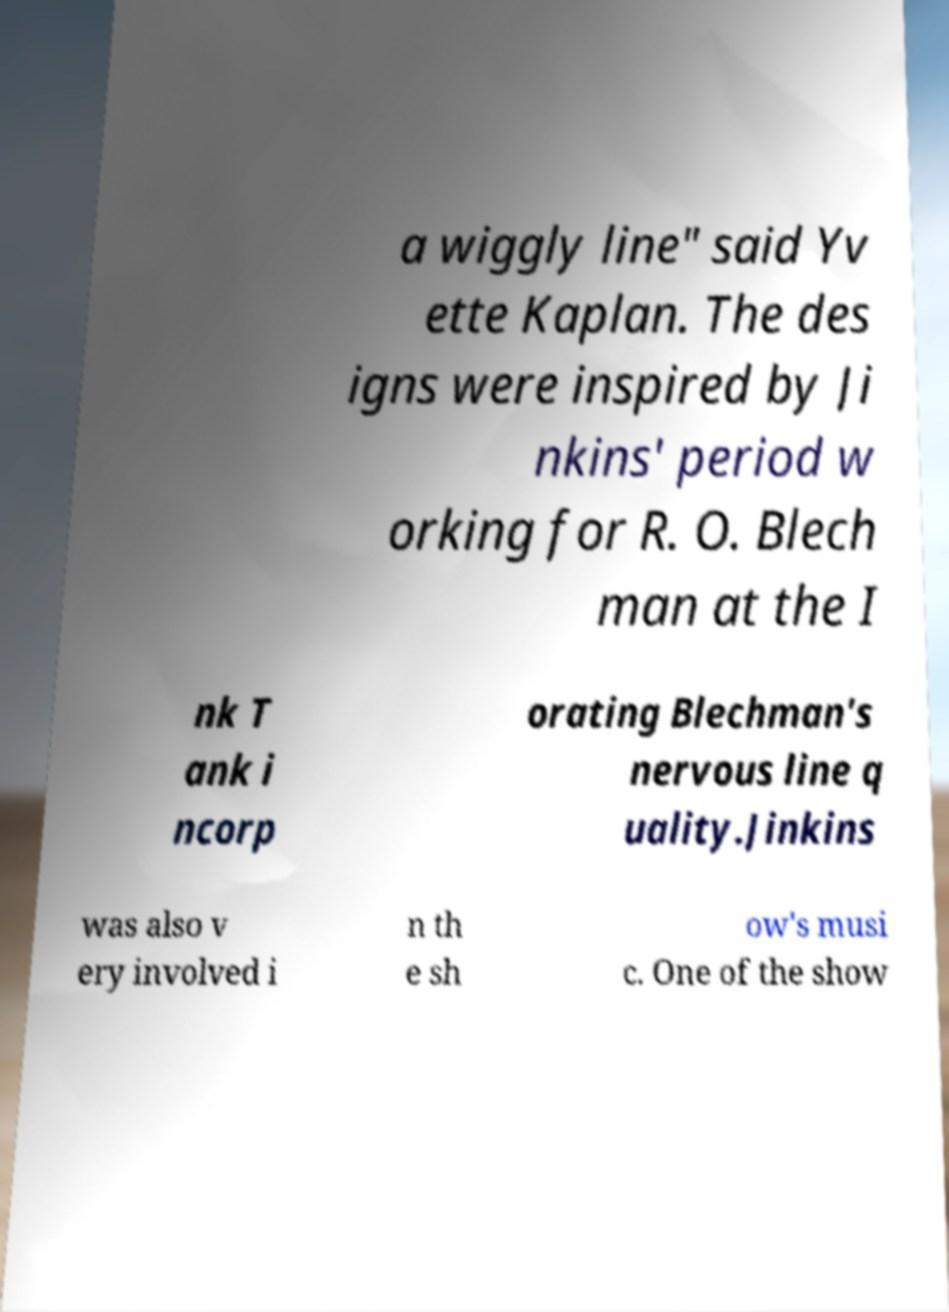Could you extract and type out the text from this image? a wiggly line" said Yv ette Kaplan. The des igns were inspired by Ji nkins' period w orking for R. O. Blech man at the I nk T ank i ncorp orating Blechman's nervous line q uality.Jinkins was also v ery involved i n th e sh ow's musi c. One of the show 